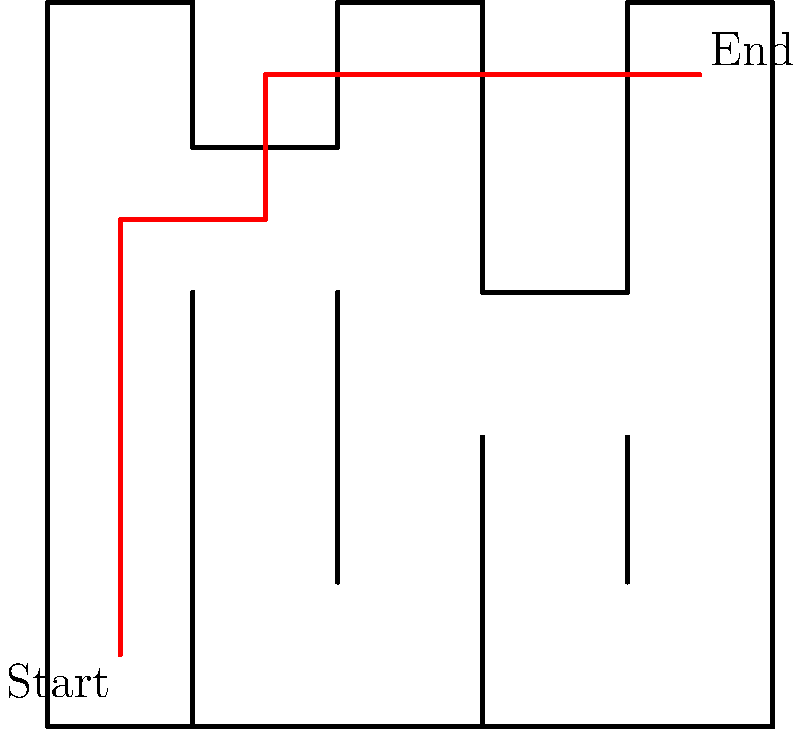In the project workflow optimization maze shown above, what is the minimum number of turns required to navigate from the "Start" point to the "End" point, assuming you can only move horizontally or vertically? To solve this problem, let's break it down step-by-step:

1. Analyze the maze structure:
   - The maze is a 5x5 grid with walls blocking certain paths.
   - We need to find the path from the bottom-left corner (Start) to the top-right corner (End).

2. Identify the optimal path:
   - Move up from Start (0,0) to (0,3)
   - Turn right and move to (1,3)
   - Turn up and move to (1,4)
   - Turn right and move to (4,4)

3. Count the number of turns:
   - First turn: From vertical to horizontal at (0,3)
   - Second turn: From horizontal to vertical at (1,3)
   - Third turn: From vertical to horizontal at (1,4)

4. Verify the solution:
   - The path described above reaches the End point (4,4) with the minimum number of turns.
   - Any other path would require either more turns or be blocked by walls.

Therefore, the minimum number of turns required is 3.
Answer: 3 turns 